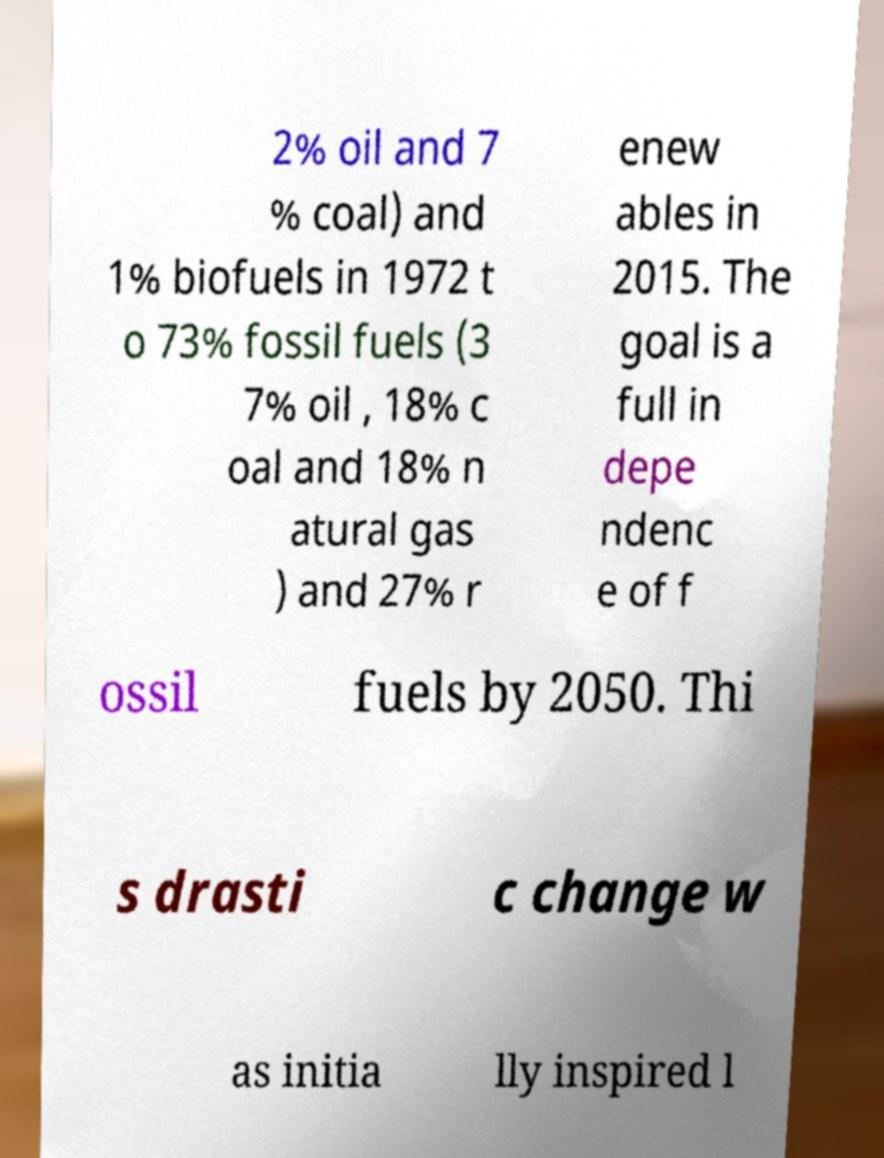Can you accurately transcribe the text from the provided image for me? 2% oil and 7 % coal) and 1% biofuels in 1972 t o 73% fossil fuels (3 7% oil , 18% c oal and 18% n atural gas ) and 27% r enew ables in 2015. The goal is a full in depe ndenc e of f ossil fuels by 2050. Thi s drasti c change w as initia lly inspired l 